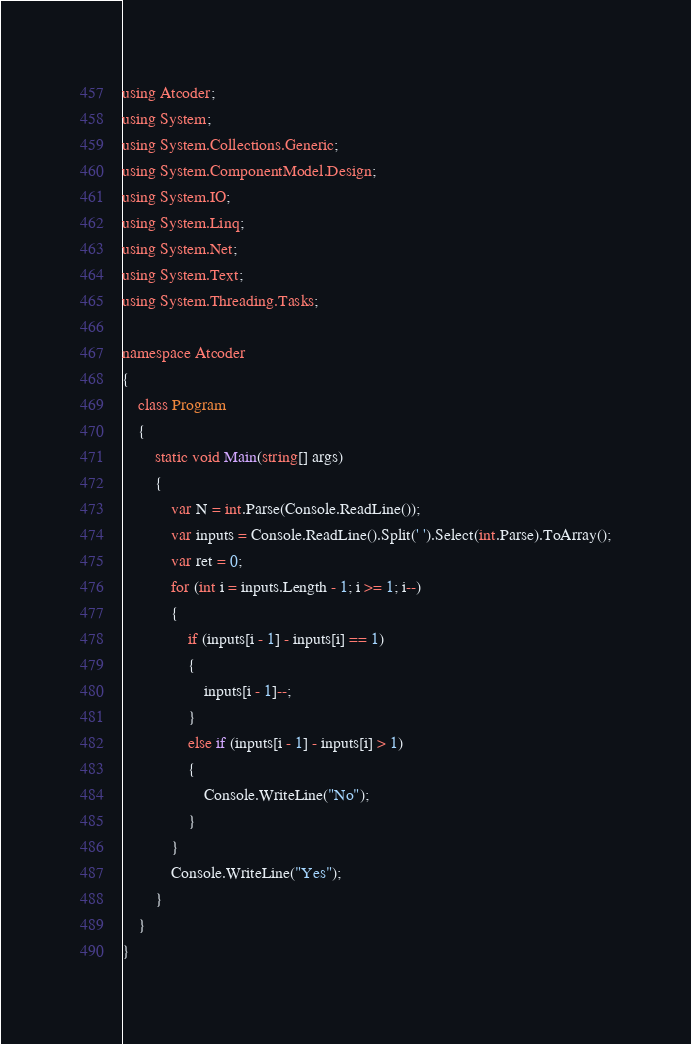Convert code to text. <code><loc_0><loc_0><loc_500><loc_500><_C#_>using Atcoder;
using System;
using System.Collections.Generic;
using System.ComponentModel.Design;
using System.IO;
using System.Linq;
using System.Net;
using System.Text;
using System.Threading.Tasks;

namespace Atcoder
{
    class Program
    {
        static void Main(string[] args)
        {
            var N = int.Parse(Console.ReadLine());
            var inputs = Console.ReadLine().Split(' ').Select(int.Parse).ToArray();
            var ret = 0;
            for (int i = inputs.Length - 1; i >= 1; i--)
            {
                if (inputs[i - 1] - inputs[i] == 1)
                {
                    inputs[i - 1]--;
                }
                else if (inputs[i - 1] - inputs[i] > 1)
                {
                    Console.WriteLine("No");
                }
            }
            Console.WriteLine("Yes");
        }
    }
}</code> 